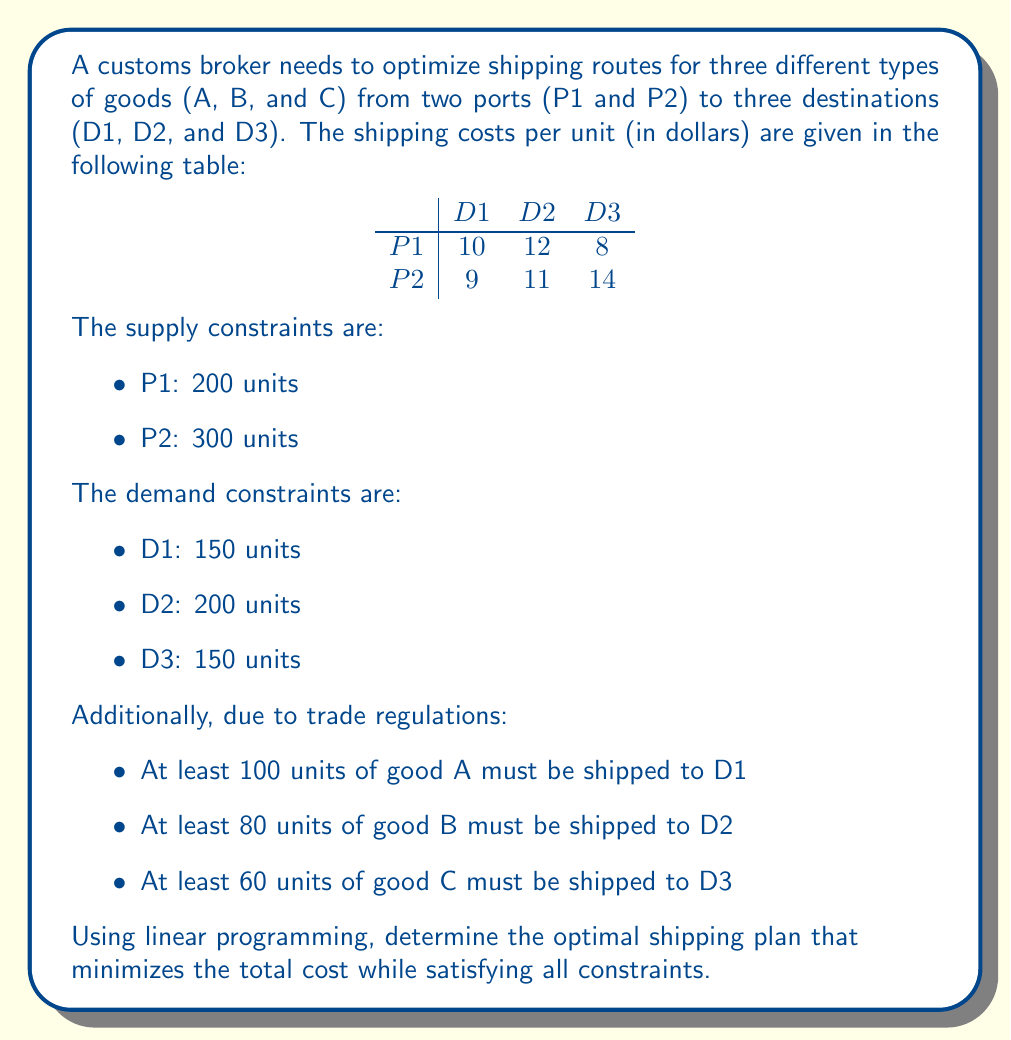Give your solution to this math problem. To solve this problem using linear programming, we need to follow these steps:

1. Define variables:
Let $x_{ij}$ represent the number of units shipped from port i to destination j.

2. Formulate the objective function:
Minimize total cost:
$$Z = 10x_{11} + 12x_{12} + 8x_{13} + 9x_{21} + 11x_{22} + 14x_{23}$$

3. Set up constraints:
Supply constraints:
$$x_{11} + x_{12} + x_{13} \leq 200$$
$$x_{21} + x_{22} + x_{23} \leq 300$$

Demand constraints:
$$x_{11} + x_{21} = 150$$
$$x_{12} + x_{22} = 200$$
$$x_{13} + x_{23} = 150$$

Trade regulation constraints:
$$x_{11} + x_{21} \geq 100$$ (Good A to D1)
$$x_{12} + x_{22} \geq 80$$ (Good B to D2)
$$x_{13} + x_{23} \geq 60$$ (Good C to D3)

Non-negativity constraints:
$$x_{ij} \geq 0$$ for all i and j

4. Solve the linear programming problem:
Using a linear programming solver (e.g., simplex method), we can find the optimal solution:

$$x_{11} = 150, x_{12} = 50, x_{13} = 0$$
$$x_{21} = 0, x_{22} = 150, x_{23} = 150$$

5. Calculate the minimum total cost:
$$Z = 10(150) + 12(50) + 8(0) + 9(0) + 11(150) + 14(150) = 5400$$

Therefore, the optimal shipping plan is:
- Ship 150 units from P1 to D1
- Ship 50 units from P1 to D2
- Ship 150 units from P2 to D2
- Ship 150 units from P2 to D3

This plan satisfies all constraints and minimizes the total shipping cost.
Answer: $5400 